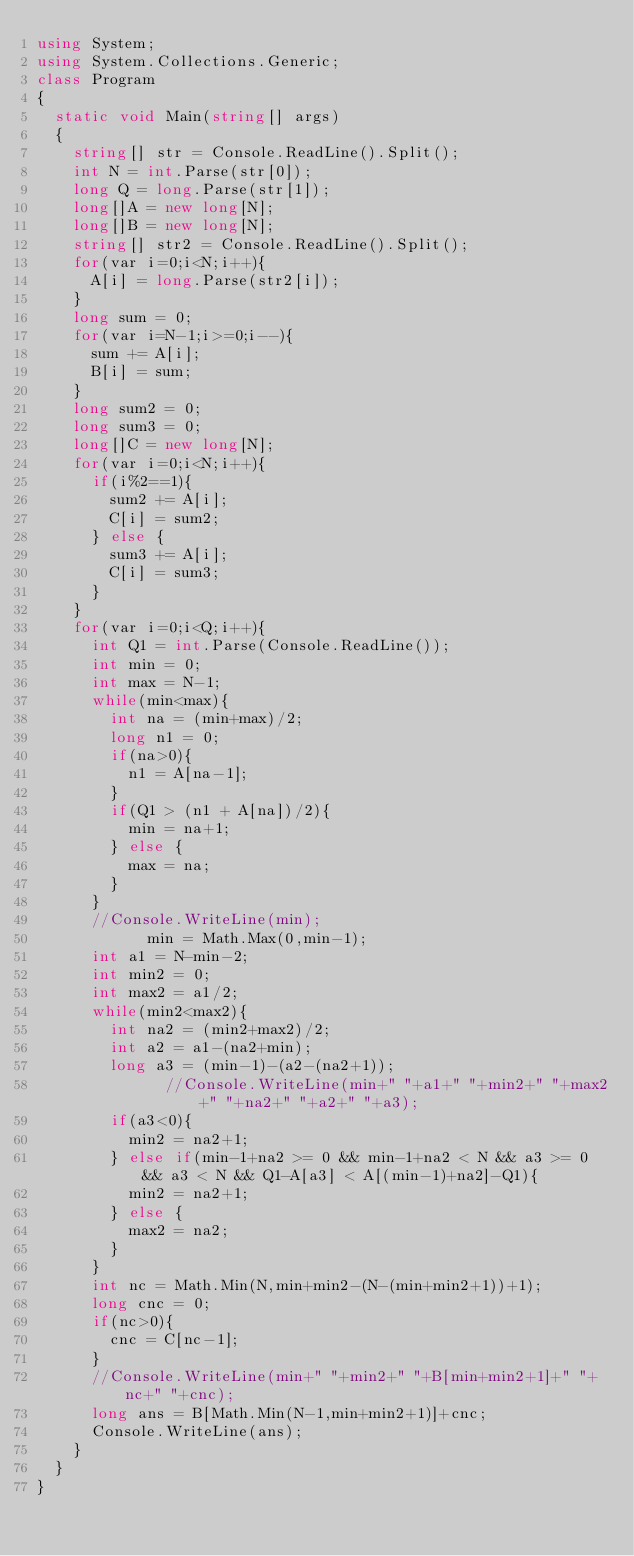<code> <loc_0><loc_0><loc_500><loc_500><_C#_>using System;
using System.Collections.Generic;
class Program
{
	static void Main(string[] args)
	{
		string[] str = Console.ReadLine().Split();
		int N = int.Parse(str[0]);
		long Q = long.Parse(str[1]);
		long[]A = new long[N];
		long[]B = new long[N];
		string[] str2 = Console.ReadLine().Split();
		for(var i=0;i<N;i++){
			A[i] = long.Parse(str2[i]);
		}
		long sum = 0;
		for(var i=N-1;i>=0;i--){
			sum += A[i];
			B[i] = sum;
		}
		long sum2 = 0;
		long sum3 = 0;
		long[]C = new long[N];
		for(var i=0;i<N;i++){
			if(i%2==1){
				sum2 += A[i];
				C[i] = sum2;
			} else {
				sum3 += A[i];
				C[i] = sum3;
			}
		}
		for(var i=0;i<Q;i++){
			int Q1 = int.Parse(Console.ReadLine());
			int min = 0;
			int max = N-1;
			while(min<max){
				int na = (min+max)/2;
				long n1 = 0;
				if(na>0){
					n1 = A[na-1];
				}
				if(Q1 > (n1 + A[na])/2){
					min = na+1;
				} else {
					max = na;
				}
			}
			//Console.WriteLine(min);
          	min = Math.Max(0,min-1);
			int a1 = N-min-2;
			int min2 = 0;
			int max2 = a1/2;
			while(min2<max2){	
				int na2 = (min2+max2)/2;
				int a2 = a1-(na2+min);
				long a3 = (min-1)-(a2-(na2+1));
              //Console.WriteLine(min+" "+a1+" "+min2+" "+max2+" "+na2+" "+a2+" "+a3);	
				if(a3<0){
					min2 = na2+1;
				} else if(min-1+na2 >= 0 && min-1+na2 < N && a3 >= 0 && a3 < N && Q1-A[a3] < A[(min-1)+na2]-Q1){
					min2 = na2+1;
				} else {
					max2 = na2;
				}
			}
			int nc = Math.Min(N,min+min2-(N-(min+min2+1))+1);
			long cnc = 0;
			if(nc>0){
				cnc = C[nc-1];
			}
			//Console.WriteLine(min+" "+min2+" "+B[min+min2+1]+" "+nc+" "+cnc);
			long ans = B[Math.Min(N-1,min+min2+1)]+cnc;
			Console.WriteLine(ans);
		}
	}
}</code> 